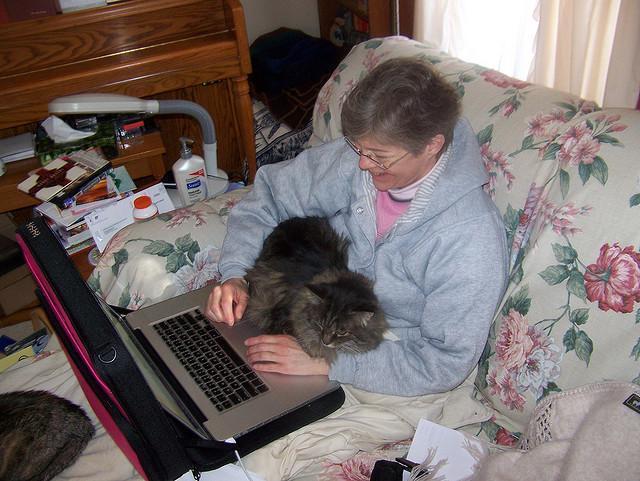How many cats are there?
Give a very brief answer. 2. 